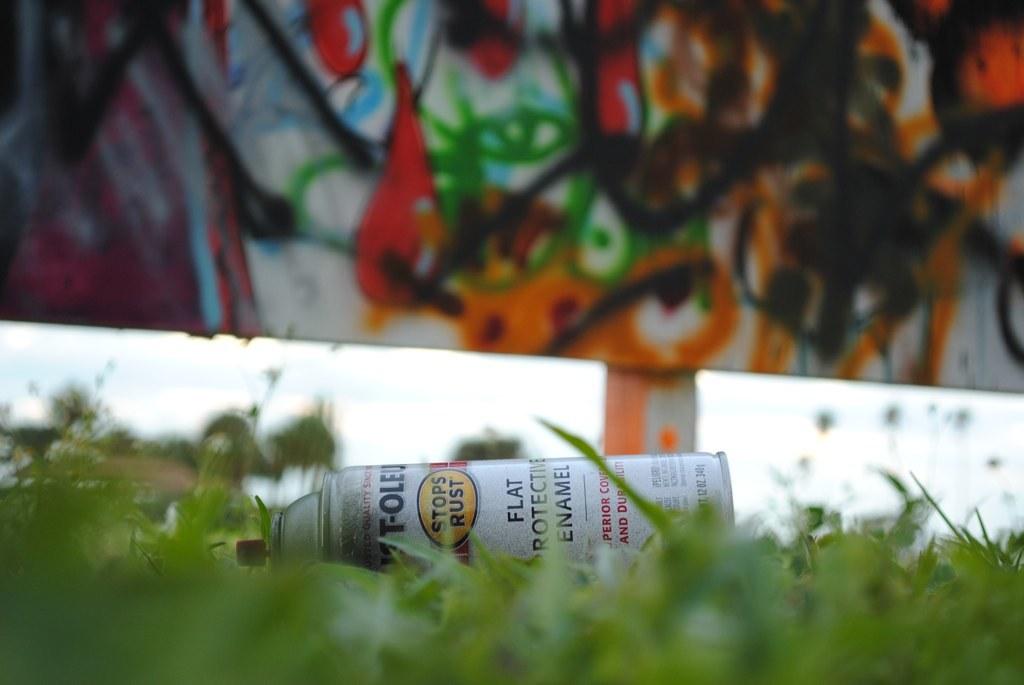What spray paint is that?
Your answer should be compact. Flat. 